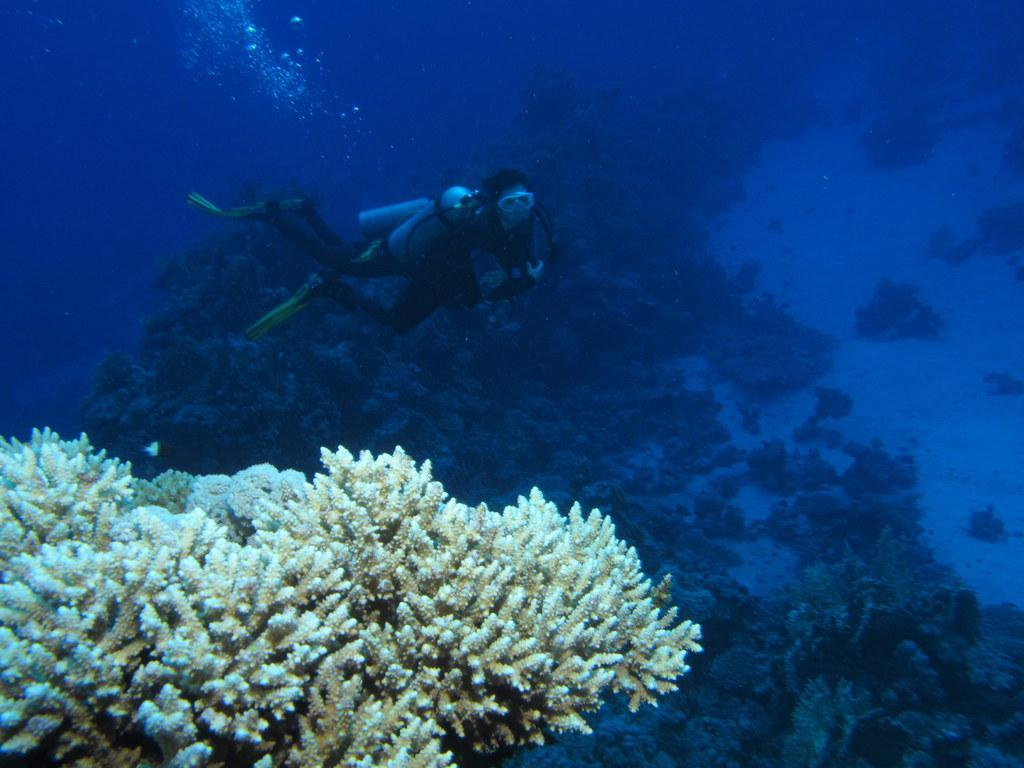Where is the image taken? The image is taken inside the water. What is the person in the image doing? There is a person swimming in the image. What can be seen at the bottom of the image? There are plants visible at the bottom of the image. What is the primary element visible in the image? There is water visible in the image. What type of peace can be seen in the image? There is no reference to peace in the image, as it features a person swimming underwater with plants and water visible. 